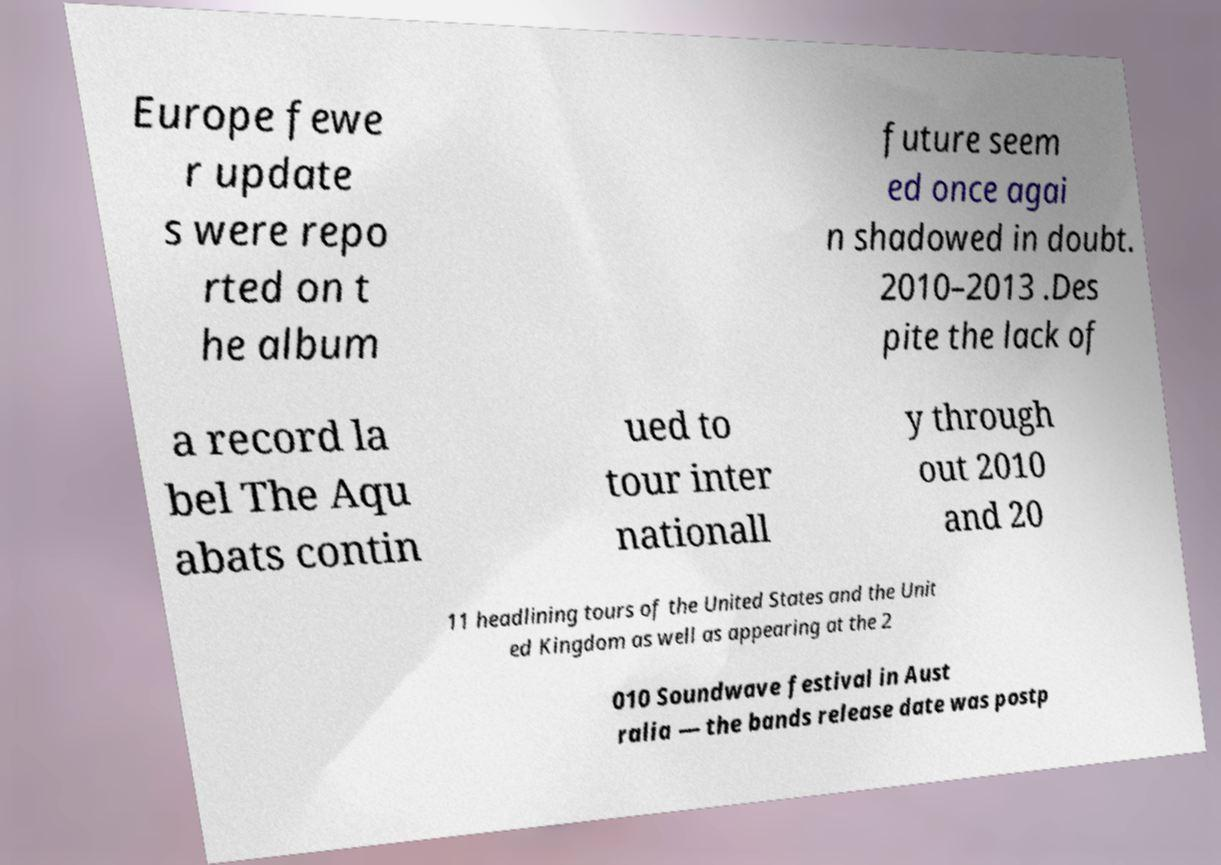I need the written content from this picture converted into text. Can you do that? Europe fewe r update s were repo rted on t he album future seem ed once agai n shadowed in doubt. 2010–2013 .Des pite the lack of a record la bel The Aqu abats contin ued to tour inter nationall y through out 2010 and 20 11 headlining tours of the United States and the Unit ed Kingdom as well as appearing at the 2 010 Soundwave festival in Aust ralia — the bands release date was postp 